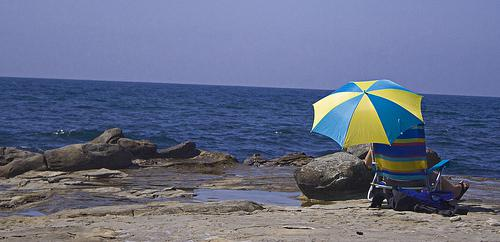Question: what colors are the umbrella?
Choices:
A. Blue, yellow.
B. Black, green.
C. Purple, red.
D. Mauve, teal.
Answer with the letter. Answer: A Question: why is the person using an umbrella?
Choices:
A. Protection from rain.
B. Protection from hail.
C. Protection from sun.
D. Protection from snow.
Answer with the letter. Answer: C Question: where was this photo taken?
Choices:
A. In the garage.
B. Beach.
C. At the dump.
D. At the store.
Answer with the letter. Answer: B Question: what color are the rocks?
Choices:
A. Brown.
B. Red.
C. Grey.
D. White.
Answer with the letter. Answer: C 